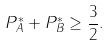<formula> <loc_0><loc_0><loc_500><loc_500>P _ { A } ^ { \ast } + P _ { B } ^ { \ast } \geq \frac { 3 } { 2 } .</formula> 